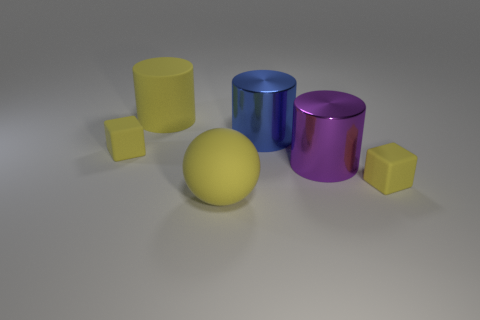What are the colors of the cylinders? There are three cylinders in the image: one is yellow, one is blue, and the other is purple. 